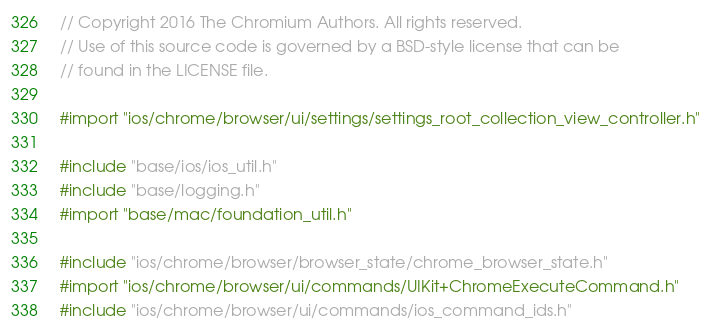Convert code to text. <code><loc_0><loc_0><loc_500><loc_500><_ObjectiveC_>// Copyright 2016 The Chromium Authors. All rights reserved.
// Use of this source code is governed by a BSD-style license that can be
// found in the LICENSE file.

#import "ios/chrome/browser/ui/settings/settings_root_collection_view_controller.h"

#include "base/ios/ios_util.h"
#include "base/logging.h"
#import "base/mac/foundation_util.h"

#include "ios/chrome/browser/browser_state/chrome_browser_state.h"
#import "ios/chrome/browser/ui/commands/UIKit+ChromeExecuteCommand.h"
#include "ios/chrome/browser/ui/commands/ios_command_ids.h"</code> 